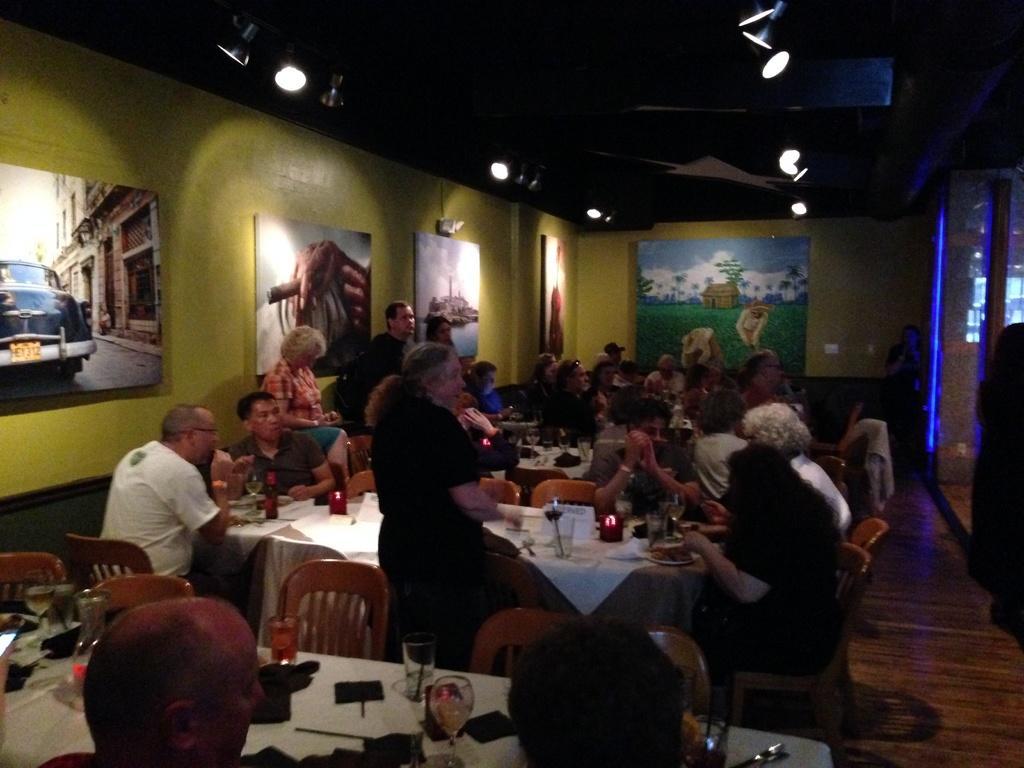In one or two sentences, can you explain what this image depicts? In the picture we can see a set of people sitting on a chairs near the table, and on the table we can find a white cloth with some glasses, bottles and wine. In the background also we can see some set of people sitting on a chairs near the table and on the walls we can see the paintings and ceiling we can see the lights. 